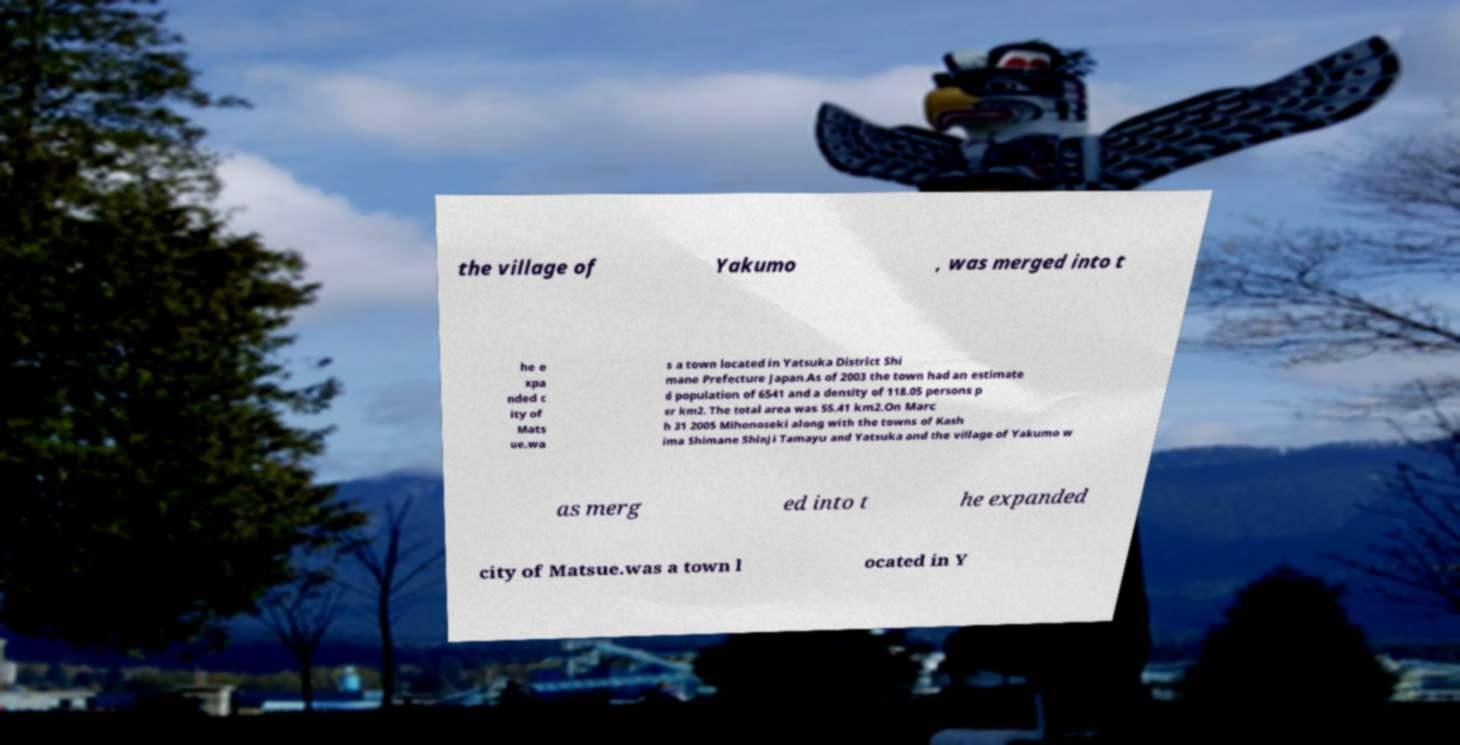There's text embedded in this image that I need extracted. Can you transcribe it verbatim? the village of Yakumo , was merged into t he e xpa nded c ity of Mats ue.wa s a town located in Yatsuka District Shi mane Prefecture Japan.As of 2003 the town had an estimate d population of 6541 and a density of 118.05 persons p er km2. The total area was 55.41 km2.On Marc h 31 2005 Mihonoseki along with the towns of Kash ima Shimane Shinji Tamayu and Yatsuka and the village of Yakumo w as merg ed into t he expanded city of Matsue.was a town l ocated in Y 